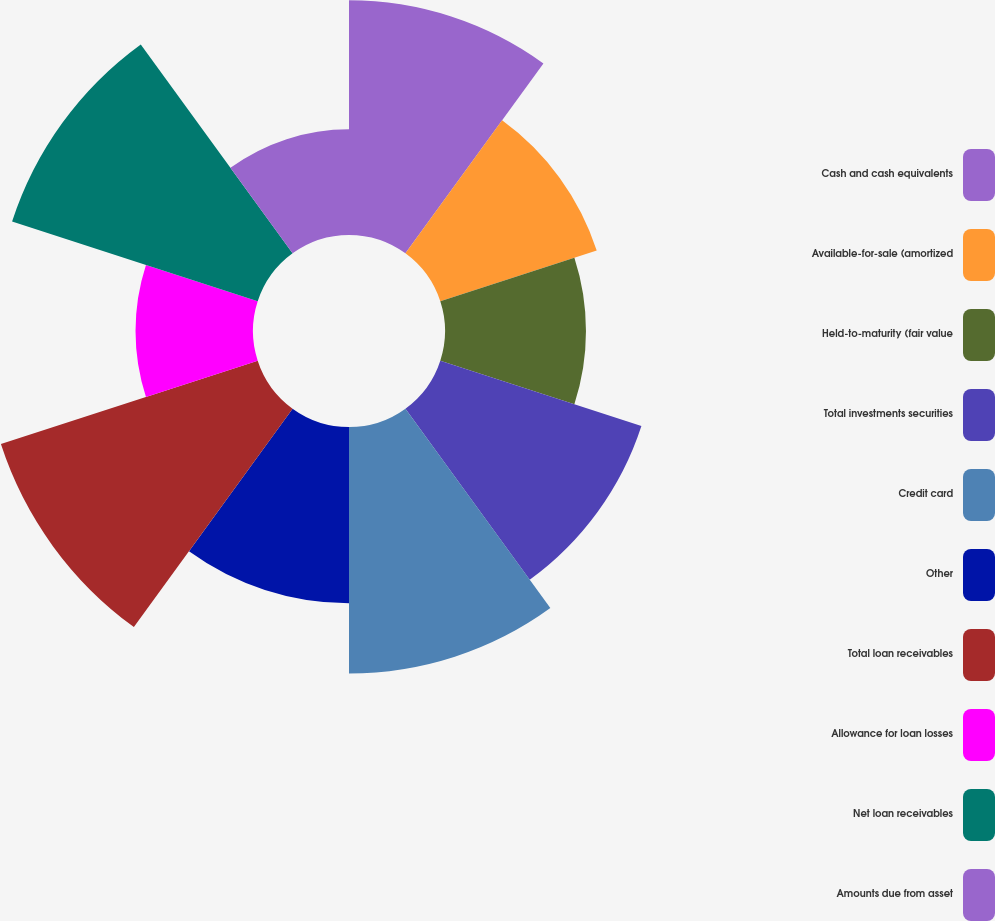Convert chart. <chart><loc_0><loc_0><loc_500><loc_500><pie_chart><fcel>Cash and cash equivalents<fcel>Available-for-sale (amortized<fcel>Held-to-maturity (fair value<fcel>Total investments securities<fcel>Credit card<fcel>Other<fcel>Total loan receivables<fcel>Allowance for loan losses<fcel>Net loan receivables<fcel>Amounts due from asset<nl><fcel>12.19%<fcel>8.54%<fcel>7.32%<fcel>10.98%<fcel>12.8%<fcel>9.15%<fcel>14.02%<fcel>6.1%<fcel>13.41%<fcel>5.49%<nl></chart> 